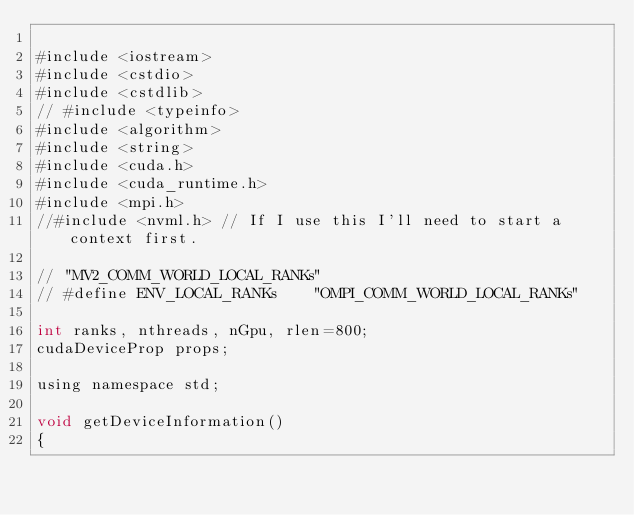Convert code to text. <code><loc_0><loc_0><loc_500><loc_500><_Cuda_>
#include <iostream>
#include <cstdio>
#include <cstdlib>
// #include <typeinfo>
#include <algorithm>
#include <string>
#include <cuda.h>
#include <cuda_runtime.h>
#include <mpi.h>
//#include <nvml.h> // If I use this I'll need to start a context first.

// "MV2_COMM_WORLD_LOCAL_RANKs"
// #define ENV_LOCAL_RANKs		"OMPI_COMM_WORLD_LOCAL_RANKs"

int ranks, nthreads, nGpu, rlen=800;
cudaDeviceProp props;

using namespace std;

void getDeviceInformation()
{</code> 